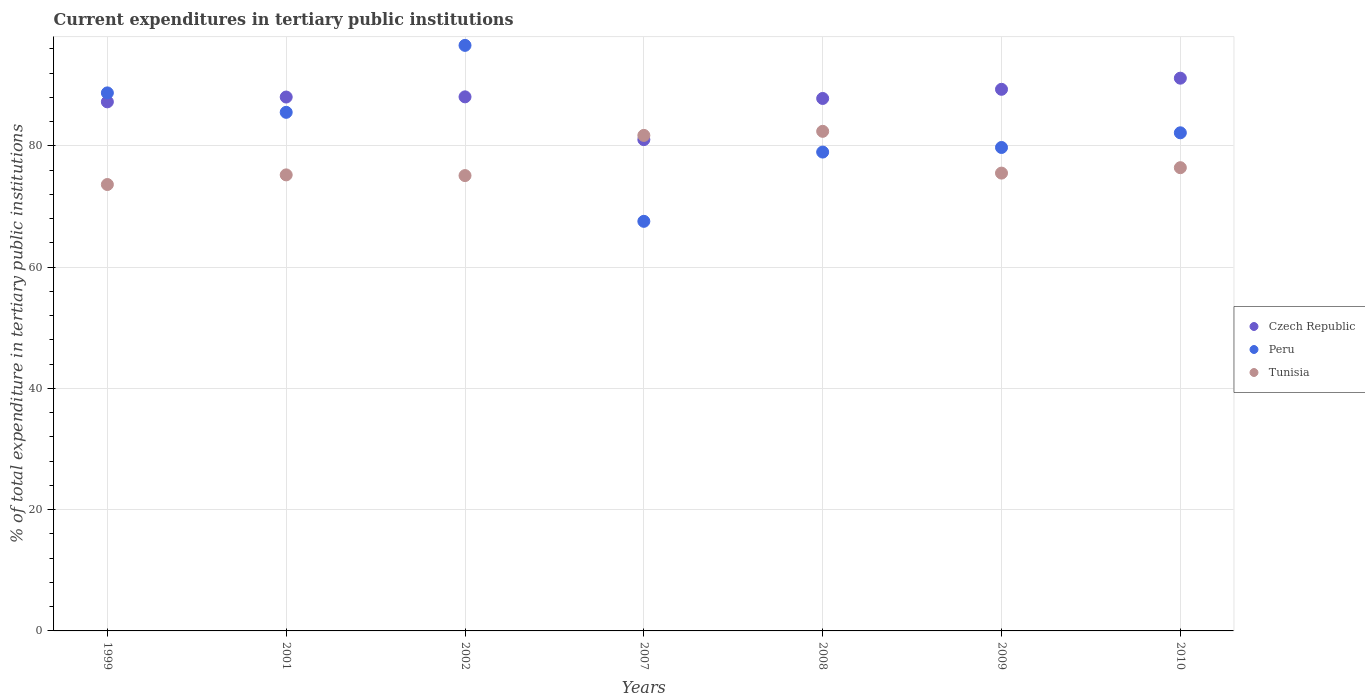Is the number of dotlines equal to the number of legend labels?
Provide a succinct answer. Yes. What is the current expenditures in tertiary public institutions in Peru in 2009?
Give a very brief answer. 79.75. Across all years, what is the maximum current expenditures in tertiary public institutions in Tunisia?
Your answer should be very brief. 82.41. Across all years, what is the minimum current expenditures in tertiary public institutions in Tunisia?
Offer a terse response. 73.64. What is the total current expenditures in tertiary public institutions in Czech Republic in the graph?
Your answer should be compact. 612.87. What is the difference between the current expenditures in tertiary public institutions in Peru in 2008 and that in 2009?
Offer a very short reply. -0.76. What is the difference between the current expenditures in tertiary public institutions in Peru in 1999 and the current expenditures in tertiary public institutions in Tunisia in 2009?
Provide a succinct answer. 13.23. What is the average current expenditures in tertiary public institutions in Czech Republic per year?
Offer a very short reply. 87.55. In the year 2009, what is the difference between the current expenditures in tertiary public institutions in Tunisia and current expenditures in tertiary public institutions in Czech Republic?
Ensure brevity in your answer.  -13.82. What is the ratio of the current expenditures in tertiary public institutions in Peru in 1999 to that in 2001?
Provide a succinct answer. 1.04. Is the current expenditures in tertiary public institutions in Tunisia in 1999 less than that in 2002?
Your answer should be very brief. Yes. What is the difference between the highest and the second highest current expenditures in tertiary public institutions in Peru?
Your response must be concise. 7.84. What is the difference between the highest and the lowest current expenditures in tertiary public institutions in Tunisia?
Your answer should be very brief. 8.77. In how many years, is the current expenditures in tertiary public institutions in Czech Republic greater than the average current expenditures in tertiary public institutions in Czech Republic taken over all years?
Your answer should be compact. 5. Does the current expenditures in tertiary public institutions in Peru monotonically increase over the years?
Your answer should be compact. No. Is the current expenditures in tertiary public institutions in Czech Republic strictly less than the current expenditures in tertiary public institutions in Tunisia over the years?
Keep it short and to the point. No. How many dotlines are there?
Make the answer very short. 3. How many years are there in the graph?
Offer a terse response. 7. What is the difference between two consecutive major ticks on the Y-axis?
Give a very brief answer. 20. Are the values on the major ticks of Y-axis written in scientific E-notation?
Provide a short and direct response. No. Does the graph contain any zero values?
Your answer should be very brief. No. Does the graph contain grids?
Offer a very short reply. Yes. What is the title of the graph?
Ensure brevity in your answer.  Current expenditures in tertiary public institutions. What is the label or title of the Y-axis?
Provide a succinct answer. % of total expenditure in tertiary public institutions. What is the % of total expenditure in tertiary public institutions of Czech Republic in 1999?
Make the answer very short. 87.28. What is the % of total expenditure in tertiary public institutions of Peru in 1999?
Keep it short and to the point. 88.76. What is the % of total expenditure in tertiary public institutions in Tunisia in 1999?
Ensure brevity in your answer.  73.64. What is the % of total expenditure in tertiary public institutions in Czech Republic in 2001?
Your answer should be very brief. 88.07. What is the % of total expenditure in tertiary public institutions in Peru in 2001?
Your response must be concise. 85.55. What is the % of total expenditure in tertiary public institutions in Tunisia in 2001?
Your response must be concise. 75.23. What is the % of total expenditure in tertiary public institutions in Czech Republic in 2002?
Your response must be concise. 88.1. What is the % of total expenditure in tertiary public institutions of Peru in 2002?
Make the answer very short. 96.6. What is the % of total expenditure in tertiary public institutions in Tunisia in 2002?
Ensure brevity in your answer.  75.12. What is the % of total expenditure in tertiary public institutions of Czech Republic in 2007?
Provide a short and direct response. 81.05. What is the % of total expenditure in tertiary public institutions in Peru in 2007?
Ensure brevity in your answer.  67.57. What is the % of total expenditure in tertiary public institutions in Tunisia in 2007?
Your response must be concise. 81.74. What is the % of total expenditure in tertiary public institutions in Czech Republic in 2008?
Your answer should be very brief. 87.84. What is the % of total expenditure in tertiary public institutions in Peru in 2008?
Your answer should be very brief. 78.99. What is the % of total expenditure in tertiary public institutions of Tunisia in 2008?
Offer a terse response. 82.41. What is the % of total expenditure in tertiary public institutions of Czech Republic in 2009?
Make the answer very short. 89.35. What is the % of total expenditure in tertiary public institutions of Peru in 2009?
Give a very brief answer. 79.75. What is the % of total expenditure in tertiary public institutions in Tunisia in 2009?
Offer a terse response. 75.52. What is the % of total expenditure in tertiary public institutions in Czech Republic in 2010?
Make the answer very short. 91.18. What is the % of total expenditure in tertiary public institutions of Peru in 2010?
Offer a very short reply. 82.17. What is the % of total expenditure in tertiary public institutions of Tunisia in 2010?
Ensure brevity in your answer.  76.42. Across all years, what is the maximum % of total expenditure in tertiary public institutions of Czech Republic?
Ensure brevity in your answer.  91.18. Across all years, what is the maximum % of total expenditure in tertiary public institutions of Peru?
Make the answer very short. 96.6. Across all years, what is the maximum % of total expenditure in tertiary public institutions of Tunisia?
Provide a succinct answer. 82.41. Across all years, what is the minimum % of total expenditure in tertiary public institutions in Czech Republic?
Your answer should be compact. 81.05. Across all years, what is the minimum % of total expenditure in tertiary public institutions in Peru?
Give a very brief answer. 67.57. Across all years, what is the minimum % of total expenditure in tertiary public institutions in Tunisia?
Provide a succinct answer. 73.64. What is the total % of total expenditure in tertiary public institutions of Czech Republic in the graph?
Your response must be concise. 612.87. What is the total % of total expenditure in tertiary public institutions in Peru in the graph?
Your answer should be compact. 579.39. What is the total % of total expenditure in tertiary public institutions of Tunisia in the graph?
Your answer should be compact. 540.09. What is the difference between the % of total expenditure in tertiary public institutions in Czech Republic in 1999 and that in 2001?
Keep it short and to the point. -0.79. What is the difference between the % of total expenditure in tertiary public institutions in Peru in 1999 and that in 2001?
Ensure brevity in your answer.  3.21. What is the difference between the % of total expenditure in tertiary public institutions in Tunisia in 1999 and that in 2001?
Offer a very short reply. -1.59. What is the difference between the % of total expenditure in tertiary public institutions of Czech Republic in 1999 and that in 2002?
Offer a terse response. -0.82. What is the difference between the % of total expenditure in tertiary public institutions of Peru in 1999 and that in 2002?
Provide a succinct answer. -7.84. What is the difference between the % of total expenditure in tertiary public institutions of Tunisia in 1999 and that in 2002?
Make the answer very short. -1.47. What is the difference between the % of total expenditure in tertiary public institutions of Czech Republic in 1999 and that in 2007?
Your response must be concise. 6.23. What is the difference between the % of total expenditure in tertiary public institutions in Peru in 1999 and that in 2007?
Offer a very short reply. 21.19. What is the difference between the % of total expenditure in tertiary public institutions of Tunisia in 1999 and that in 2007?
Your answer should be very brief. -8.1. What is the difference between the % of total expenditure in tertiary public institutions in Czech Republic in 1999 and that in 2008?
Make the answer very short. -0.56. What is the difference between the % of total expenditure in tertiary public institutions in Peru in 1999 and that in 2008?
Provide a short and direct response. 9.76. What is the difference between the % of total expenditure in tertiary public institutions in Tunisia in 1999 and that in 2008?
Your answer should be very brief. -8.77. What is the difference between the % of total expenditure in tertiary public institutions of Czech Republic in 1999 and that in 2009?
Provide a succinct answer. -2.07. What is the difference between the % of total expenditure in tertiary public institutions in Peru in 1999 and that in 2009?
Give a very brief answer. 9. What is the difference between the % of total expenditure in tertiary public institutions in Tunisia in 1999 and that in 2009?
Your answer should be compact. -1.88. What is the difference between the % of total expenditure in tertiary public institutions of Czech Republic in 1999 and that in 2010?
Your answer should be very brief. -3.9. What is the difference between the % of total expenditure in tertiary public institutions in Peru in 1999 and that in 2010?
Give a very brief answer. 6.58. What is the difference between the % of total expenditure in tertiary public institutions in Tunisia in 1999 and that in 2010?
Your answer should be very brief. -2.78. What is the difference between the % of total expenditure in tertiary public institutions in Czech Republic in 2001 and that in 2002?
Offer a terse response. -0.03. What is the difference between the % of total expenditure in tertiary public institutions of Peru in 2001 and that in 2002?
Your answer should be very brief. -11.05. What is the difference between the % of total expenditure in tertiary public institutions in Tunisia in 2001 and that in 2002?
Provide a succinct answer. 0.12. What is the difference between the % of total expenditure in tertiary public institutions of Czech Republic in 2001 and that in 2007?
Your response must be concise. 7.02. What is the difference between the % of total expenditure in tertiary public institutions of Peru in 2001 and that in 2007?
Your answer should be very brief. 17.98. What is the difference between the % of total expenditure in tertiary public institutions of Tunisia in 2001 and that in 2007?
Offer a very short reply. -6.51. What is the difference between the % of total expenditure in tertiary public institutions in Czech Republic in 2001 and that in 2008?
Your response must be concise. 0.24. What is the difference between the % of total expenditure in tertiary public institutions of Peru in 2001 and that in 2008?
Provide a short and direct response. 6.55. What is the difference between the % of total expenditure in tertiary public institutions in Tunisia in 2001 and that in 2008?
Your answer should be compact. -7.18. What is the difference between the % of total expenditure in tertiary public institutions in Czech Republic in 2001 and that in 2009?
Your answer should be very brief. -1.27. What is the difference between the % of total expenditure in tertiary public institutions of Peru in 2001 and that in 2009?
Offer a very short reply. 5.8. What is the difference between the % of total expenditure in tertiary public institutions in Tunisia in 2001 and that in 2009?
Give a very brief answer. -0.29. What is the difference between the % of total expenditure in tertiary public institutions of Czech Republic in 2001 and that in 2010?
Give a very brief answer. -3.11. What is the difference between the % of total expenditure in tertiary public institutions in Peru in 2001 and that in 2010?
Offer a very short reply. 3.38. What is the difference between the % of total expenditure in tertiary public institutions in Tunisia in 2001 and that in 2010?
Offer a terse response. -1.19. What is the difference between the % of total expenditure in tertiary public institutions in Czech Republic in 2002 and that in 2007?
Provide a short and direct response. 7.05. What is the difference between the % of total expenditure in tertiary public institutions of Peru in 2002 and that in 2007?
Keep it short and to the point. 29.03. What is the difference between the % of total expenditure in tertiary public institutions in Tunisia in 2002 and that in 2007?
Provide a succinct answer. -6.63. What is the difference between the % of total expenditure in tertiary public institutions in Czech Republic in 2002 and that in 2008?
Keep it short and to the point. 0.26. What is the difference between the % of total expenditure in tertiary public institutions in Peru in 2002 and that in 2008?
Provide a succinct answer. 17.6. What is the difference between the % of total expenditure in tertiary public institutions in Tunisia in 2002 and that in 2008?
Your response must be concise. -7.3. What is the difference between the % of total expenditure in tertiary public institutions of Czech Republic in 2002 and that in 2009?
Keep it short and to the point. -1.25. What is the difference between the % of total expenditure in tertiary public institutions in Peru in 2002 and that in 2009?
Provide a succinct answer. 16.84. What is the difference between the % of total expenditure in tertiary public institutions in Tunisia in 2002 and that in 2009?
Provide a succinct answer. -0.41. What is the difference between the % of total expenditure in tertiary public institutions of Czech Republic in 2002 and that in 2010?
Ensure brevity in your answer.  -3.08. What is the difference between the % of total expenditure in tertiary public institutions in Peru in 2002 and that in 2010?
Provide a short and direct response. 14.42. What is the difference between the % of total expenditure in tertiary public institutions of Tunisia in 2002 and that in 2010?
Keep it short and to the point. -1.3. What is the difference between the % of total expenditure in tertiary public institutions in Czech Republic in 2007 and that in 2008?
Give a very brief answer. -6.79. What is the difference between the % of total expenditure in tertiary public institutions of Peru in 2007 and that in 2008?
Offer a very short reply. -11.43. What is the difference between the % of total expenditure in tertiary public institutions in Tunisia in 2007 and that in 2008?
Provide a short and direct response. -0.67. What is the difference between the % of total expenditure in tertiary public institutions in Czech Republic in 2007 and that in 2009?
Your response must be concise. -8.3. What is the difference between the % of total expenditure in tertiary public institutions in Peru in 2007 and that in 2009?
Ensure brevity in your answer.  -12.18. What is the difference between the % of total expenditure in tertiary public institutions of Tunisia in 2007 and that in 2009?
Ensure brevity in your answer.  6.22. What is the difference between the % of total expenditure in tertiary public institutions in Czech Republic in 2007 and that in 2010?
Make the answer very short. -10.14. What is the difference between the % of total expenditure in tertiary public institutions in Peru in 2007 and that in 2010?
Your response must be concise. -14.61. What is the difference between the % of total expenditure in tertiary public institutions of Tunisia in 2007 and that in 2010?
Your answer should be very brief. 5.33. What is the difference between the % of total expenditure in tertiary public institutions of Czech Republic in 2008 and that in 2009?
Give a very brief answer. -1.51. What is the difference between the % of total expenditure in tertiary public institutions of Peru in 2008 and that in 2009?
Provide a succinct answer. -0.76. What is the difference between the % of total expenditure in tertiary public institutions in Tunisia in 2008 and that in 2009?
Provide a succinct answer. 6.89. What is the difference between the % of total expenditure in tertiary public institutions of Czech Republic in 2008 and that in 2010?
Provide a succinct answer. -3.35. What is the difference between the % of total expenditure in tertiary public institutions in Peru in 2008 and that in 2010?
Give a very brief answer. -3.18. What is the difference between the % of total expenditure in tertiary public institutions of Tunisia in 2008 and that in 2010?
Keep it short and to the point. 6. What is the difference between the % of total expenditure in tertiary public institutions in Czech Republic in 2009 and that in 2010?
Your response must be concise. -1.84. What is the difference between the % of total expenditure in tertiary public institutions of Peru in 2009 and that in 2010?
Your response must be concise. -2.42. What is the difference between the % of total expenditure in tertiary public institutions in Tunisia in 2009 and that in 2010?
Offer a terse response. -0.89. What is the difference between the % of total expenditure in tertiary public institutions of Czech Republic in 1999 and the % of total expenditure in tertiary public institutions of Peru in 2001?
Your answer should be compact. 1.73. What is the difference between the % of total expenditure in tertiary public institutions of Czech Republic in 1999 and the % of total expenditure in tertiary public institutions of Tunisia in 2001?
Ensure brevity in your answer.  12.05. What is the difference between the % of total expenditure in tertiary public institutions in Peru in 1999 and the % of total expenditure in tertiary public institutions in Tunisia in 2001?
Keep it short and to the point. 13.52. What is the difference between the % of total expenditure in tertiary public institutions of Czech Republic in 1999 and the % of total expenditure in tertiary public institutions of Peru in 2002?
Provide a short and direct response. -9.32. What is the difference between the % of total expenditure in tertiary public institutions of Czech Republic in 1999 and the % of total expenditure in tertiary public institutions of Tunisia in 2002?
Offer a very short reply. 12.16. What is the difference between the % of total expenditure in tertiary public institutions of Peru in 1999 and the % of total expenditure in tertiary public institutions of Tunisia in 2002?
Offer a very short reply. 13.64. What is the difference between the % of total expenditure in tertiary public institutions of Czech Republic in 1999 and the % of total expenditure in tertiary public institutions of Peru in 2007?
Your answer should be very brief. 19.71. What is the difference between the % of total expenditure in tertiary public institutions of Czech Republic in 1999 and the % of total expenditure in tertiary public institutions of Tunisia in 2007?
Offer a very short reply. 5.54. What is the difference between the % of total expenditure in tertiary public institutions of Peru in 1999 and the % of total expenditure in tertiary public institutions of Tunisia in 2007?
Offer a terse response. 7.01. What is the difference between the % of total expenditure in tertiary public institutions in Czech Republic in 1999 and the % of total expenditure in tertiary public institutions in Peru in 2008?
Your answer should be very brief. 8.28. What is the difference between the % of total expenditure in tertiary public institutions in Czech Republic in 1999 and the % of total expenditure in tertiary public institutions in Tunisia in 2008?
Keep it short and to the point. 4.87. What is the difference between the % of total expenditure in tertiary public institutions of Peru in 1999 and the % of total expenditure in tertiary public institutions of Tunisia in 2008?
Ensure brevity in your answer.  6.34. What is the difference between the % of total expenditure in tertiary public institutions of Czech Republic in 1999 and the % of total expenditure in tertiary public institutions of Peru in 2009?
Make the answer very short. 7.53. What is the difference between the % of total expenditure in tertiary public institutions of Czech Republic in 1999 and the % of total expenditure in tertiary public institutions of Tunisia in 2009?
Offer a very short reply. 11.76. What is the difference between the % of total expenditure in tertiary public institutions of Peru in 1999 and the % of total expenditure in tertiary public institutions of Tunisia in 2009?
Give a very brief answer. 13.23. What is the difference between the % of total expenditure in tertiary public institutions of Czech Republic in 1999 and the % of total expenditure in tertiary public institutions of Peru in 2010?
Provide a succinct answer. 5.11. What is the difference between the % of total expenditure in tertiary public institutions of Czech Republic in 1999 and the % of total expenditure in tertiary public institutions of Tunisia in 2010?
Offer a terse response. 10.86. What is the difference between the % of total expenditure in tertiary public institutions of Peru in 1999 and the % of total expenditure in tertiary public institutions of Tunisia in 2010?
Provide a short and direct response. 12.34. What is the difference between the % of total expenditure in tertiary public institutions in Czech Republic in 2001 and the % of total expenditure in tertiary public institutions in Peru in 2002?
Provide a succinct answer. -8.52. What is the difference between the % of total expenditure in tertiary public institutions of Czech Republic in 2001 and the % of total expenditure in tertiary public institutions of Tunisia in 2002?
Give a very brief answer. 12.96. What is the difference between the % of total expenditure in tertiary public institutions in Peru in 2001 and the % of total expenditure in tertiary public institutions in Tunisia in 2002?
Offer a terse response. 10.43. What is the difference between the % of total expenditure in tertiary public institutions of Czech Republic in 2001 and the % of total expenditure in tertiary public institutions of Peru in 2007?
Your response must be concise. 20.51. What is the difference between the % of total expenditure in tertiary public institutions in Czech Republic in 2001 and the % of total expenditure in tertiary public institutions in Tunisia in 2007?
Your answer should be very brief. 6.33. What is the difference between the % of total expenditure in tertiary public institutions in Peru in 2001 and the % of total expenditure in tertiary public institutions in Tunisia in 2007?
Keep it short and to the point. 3.81. What is the difference between the % of total expenditure in tertiary public institutions in Czech Republic in 2001 and the % of total expenditure in tertiary public institutions in Peru in 2008?
Your answer should be very brief. 9.08. What is the difference between the % of total expenditure in tertiary public institutions of Czech Republic in 2001 and the % of total expenditure in tertiary public institutions of Tunisia in 2008?
Your answer should be very brief. 5.66. What is the difference between the % of total expenditure in tertiary public institutions in Peru in 2001 and the % of total expenditure in tertiary public institutions in Tunisia in 2008?
Keep it short and to the point. 3.14. What is the difference between the % of total expenditure in tertiary public institutions of Czech Republic in 2001 and the % of total expenditure in tertiary public institutions of Peru in 2009?
Provide a succinct answer. 8.32. What is the difference between the % of total expenditure in tertiary public institutions of Czech Republic in 2001 and the % of total expenditure in tertiary public institutions of Tunisia in 2009?
Your answer should be very brief. 12.55. What is the difference between the % of total expenditure in tertiary public institutions of Peru in 2001 and the % of total expenditure in tertiary public institutions of Tunisia in 2009?
Offer a very short reply. 10.03. What is the difference between the % of total expenditure in tertiary public institutions in Czech Republic in 2001 and the % of total expenditure in tertiary public institutions in Tunisia in 2010?
Make the answer very short. 11.65. What is the difference between the % of total expenditure in tertiary public institutions in Peru in 2001 and the % of total expenditure in tertiary public institutions in Tunisia in 2010?
Ensure brevity in your answer.  9.13. What is the difference between the % of total expenditure in tertiary public institutions in Czech Republic in 2002 and the % of total expenditure in tertiary public institutions in Peru in 2007?
Make the answer very short. 20.54. What is the difference between the % of total expenditure in tertiary public institutions in Czech Republic in 2002 and the % of total expenditure in tertiary public institutions in Tunisia in 2007?
Your answer should be compact. 6.36. What is the difference between the % of total expenditure in tertiary public institutions in Peru in 2002 and the % of total expenditure in tertiary public institutions in Tunisia in 2007?
Your answer should be very brief. 14.85. What is the difference between the % of total expenditure in tertiary public institutions of Czech Republic in 2002 and the % of total expenditure in tertiary public institutions of Peru in 2008?
Ensure brevity in your answer.  9.11. What is the difference between the % of total expenditure in tertiary public institutions in Czech Republic in 2002 and the % of total expenditure in tertiary public institutions in Tunisia in 2008?
Ensure brevity in your answer.  5.69. What is the difference between the % of total expenditure in tertiary public institutions of Peru in 2002 and the % of total expenditure in tertiary public institutions of Tunisia in 2008?
Your answer should be compact. 14.18. What is the difference between the % of total expenditure in tertiary public institutions of Czech Republic in 2002 and the % of total expenditure in tertiary public institutions of Peru in 2009?
Offer a terse response. 8.35. What is the difference between the % of total expenditure in tertiary public institutions in Czech Republic in 2002 and the % of total expenditure in tertiary public institutions in Tunisia in 2009?
Ensure brevity in your answer.  12.58. What is the difference between the % of total expenditure in tertiary public institutions of Peru in 2002 and the % of total expenditure in tertiary public institutions of Tunisia in 2009?
Provide a succinct answer. 21.07. What is the difference between the % of total expenditure in tertiary public institutions in Czech Republic in 2002 and the % of total expenditure in tertiary public institutions in Peru in 2010?
Your answer should be very brief. 5.93. What is the difference between the % of total expenditure in tertiary public institutions of Czech Republic in 2002 and the % of total expenditure in tertiary public institutions of Tunisia in 2010?
Your answer should be very brief. 11.68. What is the difference between the % of total expenditure in tertiary public institutions in Peru in 2002 and the % of total expenditure in tertiary public institutions in Tunisia in 2010?
Your response must be concise. 20.18. What is the difference between the % of total expenditure in tertiary public institutions of Czech Republic in 2007 and the % of total expenditure in tertiary public institutions of Peru in 2008?
Provide a short and direct response. 2.05. What is the difference between the % of total expenditure in tertiary public institutions in Czech Republic in 2007 and the % of total expenditure in tertiary public institutions in Tunisia in 2008?
Offer a terse response. -1.37. What is the difference between the % of total expenditure in tertiary public institutions of Peru in 2007 and the % of total expenditure in tertiary public institutions of Tunisia in 2008?
Provide a succinct answer. -14.85. What is the difference between the % of total expenditure in tertiary public institutions in Czech Republic in 2007 and the % of total expenditure in tertiary public institutions in Peru in 2009?
Your answer should be compact. 1.3. What is the difference between the % of total expenditure in tertiary public institutions of Czech Republic in 2007 and the % of total expenditure in tertiary public institutions of Tunisia in 2009?
Offer a very short reply. 5.52. What is the difference between the % of total expenditure in tertiary public institutions of Peru in 2007 and the % of total expenditure in tertiary public institutions of Tunisia in 2009?
Keep it short and to the point. -7.96. What is the difference between the % of total expenditure in tertiary public institutions in Czech Republic in 2007 and the % of total expenditure in tertiary public institutions in Peru in 2010?
Give a very brief answer. -1.12. What is the difference between the % of total expenditure in tertiary public institutions of Czech Republic in 2007 and the % of total expenditure in tertiary public institutions of Tunisia in 2010?
Make the answer very short. 4.63. What is the difference between the % of total expenditure in tertiary public institutions in Peru in 2007 and the % of total expenditure in tertiary public institutions in Tunisia in 2010?
Give a very brief answer. -8.85. What is the difference between the % of total expenditure in tertiary public institutions of Czech Republic in 2008 and the % of total expenditure in tertiary public institutions of Peru in 2009?
Your answer should be compact. 8.09. What is the difference between the % of total expenditure in tertiary public institutions in Czech Republic in 2008 and the % of total expenditure in tertiary public institutions in Tunisia in 2009?
Your answer should be compact. 12.31. What is the difference between the % of total expenditure in tertiary public institutions of Peru in 2008 and the % of total expenditure in tertiary public institutions of Tunisia in 2009?
Provide a succinct answer. 3.47. What is the difference between the % of total expenditure in tertiary public institutions of Czech Republic in 2008 and the % of total expenditure in tertiary public institutions of Peru in 2010?
Offer a very short reply. 5.66. What is the difference between the % of total expenditure in tertiary public institutions of Czech Republic in 2008 and the % of total expenditure in tertiary public institutions of Tunisia in 2010?
Offer a terse response. 11.42. What is the difference between the % of total expenditure in tertiary public institutions in Peru in 2008 and the % of total expenditure in tertiary public institutions in Tunisia in 2010?
Ensure brevity in your answer.  2.58. What is the difference between the % of total expenditure in tertiary public institutions of Czech Republic in 2009 and the % of total expenditure in tertiary public institutions of Peru in 2010?
Your response must be concise. 7.17. What is the difference between the % of total expenditure in tertiary public institutions of Czech Republic in 2009 and the % of total expenditure in tertiary public institutions of Tunisia in 2010?
Provide a short and direct response. 12.93. What is the difference between the % of total expenditure in tertiary public institutions of Peru in 2009 and the % of total expenditure in tertiary public institutions of Tunisia in 2010?
Your answer should be very brief. 3.33. What is the average % of total expenditure in tertiary public institutions in Czech Republic per year?
Provide a short and direct response. 87.55. What is the average % of total expenditure in tertiary public institutions of Peru per year?
Ensure brevity in your answer.  82.77. What is the average % of total expenditure in tertiary public institutions of Tunisia per year?
Ensure brevity in your answer.  77.16. In the year 1999, what is the difference between the % of total expenditure in tertiary public institutions of Czech Republic and % of total expenditure in tertiary public institutions of Peru?
Provide a short and direct response. -1.48. In the year 1999, what is the difference between the % of total expenditure in tertiary public institutions of Czech Republic and % of total expenditure in tertiary public institutions of Tunisia?
Offer a terse response. 13.64. In the year 1999, what is the difference between the % of total expenditure in tertiary public institutions in Peru and % of total expenditure in tertiary public institutions in Tunisia?
Offer a very short reply. 15.11. In the year 2001, what is the difference between the % of total expenditure in tertiary public institutions in Czech Republic and % of total expenditure in tertiary public institutions in Peru?
Make the answer very short. 2.52. In the year 2001, what is the difference between the % of total expenditure in tertiary public institutions of Czech Republic and % of total expenditure in tertiary public institutions of Tunisia?
Offer a very short reply. 12.84. In the year 2001, what is the difference between the % of total expenditure in tertiary public institutions of Peru and % of total expenditure in tertiary public institutions of Tunisia?
Ensure brevity in your answer.  10.32. In the year 2002, what is the difference between the % of total expenditure in tertiary public institutions of Czech Republic and % of total expenditure in tertiary public institutions of Peru?
Keep it short and to the point. -8.49. In the year 2002, what is the difference between the % of total expenditure in tertiary public institutions in Czech Republic and % of total expenditure in tertiary public institutions in Tunisia?
Offer a terse response. 12.99. In the year 2002, what is the difference between the % of total expenditure in tertiary public institutions of Peru and % of total expenditure in tertiary public institutions of Tunisia?
Offer a terse response. 21.48. In the year 2007, what is the difference between the % of total expenditure in tertiary public institutions in Czech Republic and % of total expenditure in tertiary public institutions in Peru?
Offer a very short reply. 13.48. In the year 2007, what is the difference between the % of total expenditure in tertiary public institutions in Czech Republic and % of total expenditure in tertiary public institutions in Tunisia?
Offer a very short reply. -0.7. In the year 2007, what is the difference between the % of total expenditure in tertiary public institutions of Peru and % of total expenditure in tertiary public institutions of Tunisia?
Give a very brief answer. -14.18. In the year 2008, what is the difference between the % of total expenditure in tertiary public institutions in Czech Republic and % of total expenditure in tertiary public institutions in Peru?
Your answer should be compact. 8.84. In the year 2008, what is the difference between the % of total expenditure in tertiary public institutions in Czech Republic and % of total expenditure in tertiary public institutions in Tunisia?
Provide a short and direct response. 5.42. In the year 2008, what is the difference between the % of total expenditure in tertiary public institutions in Peru and % of total expenditure in tertiary public institutions in Tunisia?
Make the answer very short. -3.42. In the year 2009, what is the difference between the % of total expenditure in tertiary public institutions of Czech Republic and % of total expenditure in tertiary public institutions of Peru?
Keep it short and to the point. 9.6. In the year 2009, what is the difference between the % of total expenditure in tertiary public institutions in Czech Republic and % of total expenditure in tertiary public institutions in Tunisia?
Your answer should be very brief. 13.82. In the year 2009, what is the difference between the % of total expenditure in tertiary public institutions in Peru and % of total expenditure in tertiary public institutions in Tunisia?
Your answer should be very brief. 4.23. In the year 2010, what is the difference between the % of total expenditure in tertiary public institutions in Czech Republic and % of total expenditure in tertiary public institutions in Peru?
Give a very brief answer. 9.01. In the year 2010, what is the difference between the % of total expenditure in tertiary public institutions in Czech Republic and % of total expenditure in tertiary public institutions in Tunisia?
Your answer should be compact. 14.77. In the year 2010, what is the difference between the % of total expenditure in tertiary public institutions in Peru and % of total expenditure in tertiary public institutions in Tunisia?
Offer a terse response. 5.75. What is the ratio of the % of total expenditure in tertiary public institutions in Czech Republic in 1999 to that in 2001?
Make the answer very short. 0.99. What is the ratio of the % of total expenditure in tertiary public institutions in Peru in 1999 to that in 2001?
Your answer should be compact. 1.04. What is the ratio of the % of total expenditure in tertiary public institutions in Tunisia in 1999 to that in 2001?
Ensure brevity in your answer.  0.98. What is the ratio of the % of total expenditure in tertiary public institutions of Czech Republic in 1999 to that in 2002?
Ensure brevity in your answer.  0.99. What is the ratio of the % of total expenditure in tertiary public institutions in Peru in 1999 to that in 2002?
Provide a short and direct response. 0.92. What is the ratio of the % of total expenditure in tertiary public institutions of Tunisia in 1999 to that in 2002?
Give a very brief answer. 0.98. What is the ratio of the % of total expenditure in tertiary public institutions of Peru in 1999 to that in 2007?
Offer a terse response. 1.31. What is the ratio of the % of total expenditure in tertiary public institutions of Tunisia in 1999 to that in 2007?
Provide a succinct answer. 0.9. What is the ratio of the % of total expenditure in tertiary public institutions in Czech Republic in 1999 to that in 2008?
Your response must be concise. 0.99. What is the ratio of the % of total expenditure in tertiary public institutions of Peru in 1999 to that in 2008?
Make the answer very short. 1.12. What is the ratio of the % of total expenditure in tertiary public institutions in Tunisia in 1999 to that in 2008?
Provide a short and direct response. 0.89. What is the ratio of the % of total expenditure in tertiary public institutions in Czech Republic in 1999 to that in 2009?
Keep it short and to the point. 0.98. What is the ratio of the % of total expenditure in tertiary public institutions in Peru in 1999 to that in 2009?
Your answer should be compact. 1.11. What is the ratio of the % of total expenditure in tertiary public institutions of Tunisia in 1999 to that in 2009?
Your answer should be very brief. 0.98. What is the ratio of the % of total expenditure in tertiary public institutions of Czech Republic in 1999 to that in 2010?
Make the answer very short. 0.96. What is the ratio of the % of total expenditure in tertiary public institutions in Peru in 1999 to that in 2010?
Provide a short and direct response. 1.08. What is the ratio of the % of total expenditure in tertiary public institutions of Tunisia in 1999 to that in 2010?
Your answer should be compact. 0.96. What is the ratio of the % of total expenditure in tertiary public institutions in Peru in 2001 to that in 2002?
Your answer should be compact. 0.89. What is the ratio of the % of total expenditure in tertiary public institutions of Czech Republic in 2001 to that in 2007?
Provide a succinct answer. 1.09. What is the ratio of the % of total expenditure in tertiary public institutions of Peru in 2001 to that in 2007?
Provide a short and direct response. 1.27. What is the ratio of the % of total expenditure in tertiary public institutions in Tunisia in 2001 to that in 2007?
Your answer should be compact. 0.92. What is the ratio of the % of total expenditure in tertiary public institutions in Czech Republic in 2001 to that in 2008?
Your answer should be compact. 1. What is the ratio of the % of total expenditure in tertiary public institutions in Peru in 2001 to that in 2008?
Your answer should be very brief. 1.08. What is the ratio of the % of total expenditure in tertiary public institutions in Tunisia in 2001 to that in 2008?
Give a very brief answer. 0.91. What is the ratio of the % of total expenditure in tertiary public institutions of Czech Republic in 2001 to that in 2009?
Offer a terse response. 0.99. What is the ratio of the % of total expenditure in tertiary public institutions of Peru in 2001 to that in 2009?
Provide a succinct answer. 1.07. What is the ratio of the % of total expenditure in tertiary public institutions in Czech Republic in 2001 to that in 2010?
Provide a succinct answer. 0.97. What is the ratio of the % of total expenditure in tertiary public institutions in Peru in 2001 to that in 2010?
Give a very brief answer. 1.04. What is the ratio of the % of total expenditure in tertiary public institutions in Tunisia in 2001 to that in 2010?
Give a very brief answer. 0.98. What is the ratio of the % of total expenditure in tertiary public institutions in Czech Republic in 2002 to that in 2007?
Your answer should be very brief. 1.09. What is the ratio of the % of total expenditure in tertiary public institutions in Peru in 2002 to that in 2007?
Keep it short and to the point. 1.43. What is the ratio of the % of total expenditure in tertiary public institutions in Tunisia in 2002 to that in 2007?
Offer a very short reply. 0.92. What is the ratio of the % of total expenditure in tertiary public institutions in Czech Republic in 2002 to that in 2008?
Offer a very short reply. 1. What is the ratio of the % of total expenditure in tertiary public institutions of Peru in 2002 to that in 2008?
Keep it short and to the point. 1.22. What is the ratio of the % of total expenditure in tertiary public institutions of Tunisia in 2002 to that in 2008?
Keep it short and to the point. 0.91. What is the ratio of the % of total expenditure in tertiary public institutions in Czech Republic in 2002 to that in 2009?
Provide a succinct answer. 0.99. What is the ratio of the % of total expenditure in tertiary public institutions of Peru in 2002 to that in 2009?
Your answer should be compact. 1.21. What is the ratio of the % of total expenditure in tertiary public institutions of Czech Republic in 2002 to that in 2010?
Make the answer very short. 0.97. What is the ratio of the % of total expenditure in tertiary public institutions of Peru in 2002 to that in 2010?
Offer a very short reply. 1.18. What is the ratio of the % of total expenditure in tertiary public institutions of Tunisia in 2002 to that in 2010?
Keep it short and to the point. 0.98. What is the ratio of the % of total expenditure in tertiary public institutions in Czech Republic in 2007 to that in 2008?
Your answer should be very brief. 0.92. What is the ratio of the % of total expenditure in tertiary public institutions in Peru in 2007 to that in 2008?
Offer a terse response. 0.86. What is the ratio of the % of total expenditure in tertiary public institutions of Tunisia in 2007 to that in 2008?
Provide a short and direct response. 0.99. What is the ratio of the % of total expenditure in tertiary public institutions in Czech Republic in 2007 to that in 2009?
Your response must be concise. 0.91. What is the ratio of the % of total expenditure in tertiary public institutions in Peru in 2007 to that in 2009?
Your response must be concise. 0.85. What is the ratio of the % of total expenditure in tertiary public institutions in Tunisia in 2007 to that in 2009?
Make the answer very short. 1.08. What is the ratio of the % of total expenditure in tertiary public institutions in Czech Republic in 2007 to that in 2010?
Your answer should be compact. 0.89. What is the ratio of the % of total expenditure in tertiary public institutions in Peru in 2007 to that in 2010?
Your answer should be very brief. 0.82. What is the ratio of the % of total expenditure in tertiary public institutions of Tunisia in 2007 to that in 2010?
Offer a terse response. 1.07. What is the ratio of the % of total expenditure in tertiary public institutions of Czech Republic in 2008 to that in 2009?
Your response must be concise. 0.98. What is the ratio of the % of total expenditure in tertiary public institutions in Tunisia in 2008 to that in 2009?
Your answer should be very brief. 1.09. What is the ratio of the % of total expenditure in tertiary public institutions in Czech Republic in 2008 to that in 2010?
Your answer should be very brief. 0.96. What is the ratio of the % of total expenditure in tertiary public institutions of Peru in 2008 to that in 2010?
Offer a very short reply. 0.96. What is the ratio of the % of total expenditure in tertiary public institutions of Tunisia in 2008 to that in 2010?
Give a very brief answer. 1.08. What is the ratio of the % of total expenditure in tertiary public institutions in Czech Republic in 2009 to that in 2010?
Ensure brevity in your answer.  0.98. What is the ratio of the % of total expenditure in tertiary public institutions in Peru in 2009 to that in 2010?
Keep it short and to the point. 0.97. What is the ratio of the % of total expenditure in tertiary public institutions of Tunisia in 2009 to that in 2010?
Give a very brief answer. 0.99. What is the difference between the highest and the second highest % of total expenditure in tertiary public institutions of Czech Republic?
Your answer should be very brief. 1.84. What is the difference between the highest and the second highest % of total expenditure in tertiary public institutions in Peru?
Ensure brevity in your answer.  7.84. What is the difference between the highest and the second highest % of total expenditure in tertiary public institutions of Tunisia?
Offer a very short reply. 0.67. What is the difference between the highest and the lowest % of total expenditure in tertiary public institutions of Czech Republic?
Your answer should be very brief. 10.14. What is the difference between the highest and the lowest % of total expenditure in tertiary public institutions in Peru?
Make the answer very short. 29.03. What is the difference between the highest and the lowest % of total expenditure in tertiary public institutions in Tunisia?
Offer a very short reply. 8.77. 